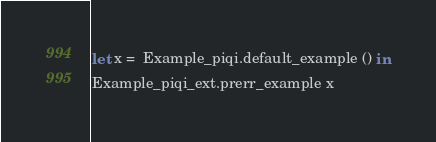<code> <loc_0><loc_0><loc_500><loc_500><_OCaml_>let x =  Example_piqi.default_example () in
Example_piqi_ext.prerr_example x
</code> 